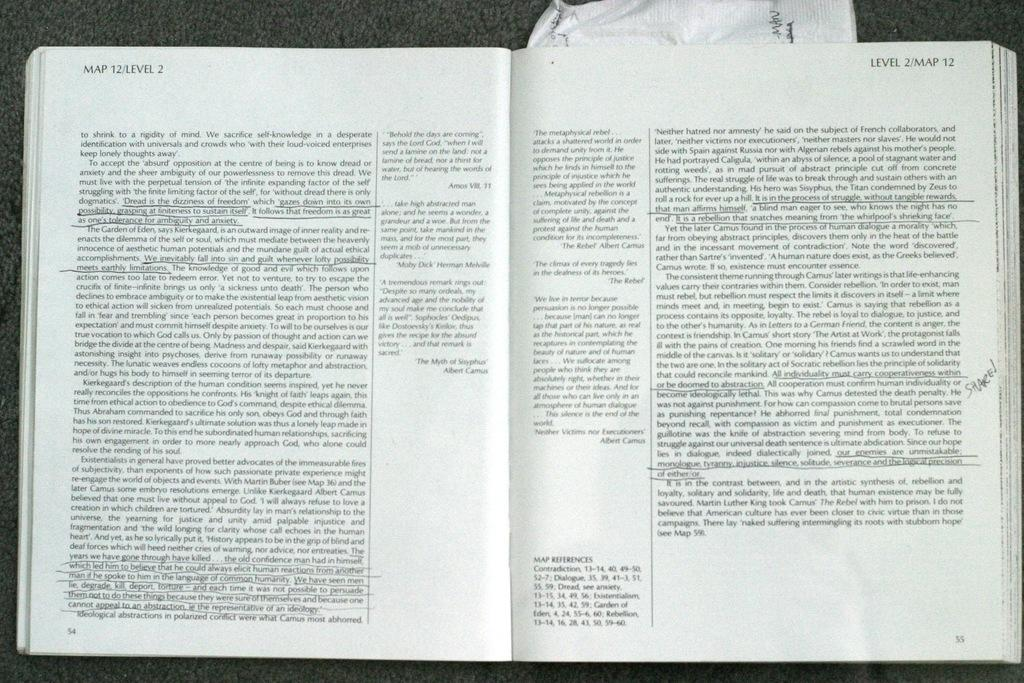<image>
Render a clear and concise summary of the photo. An open text book with title page reading Map12/Level 2. 